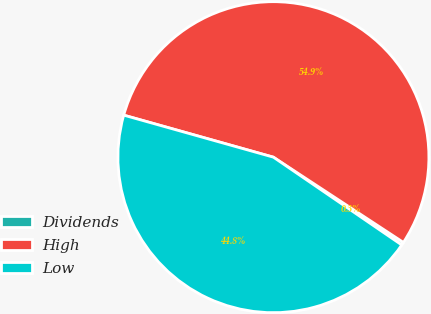<chart> <loc_0><loc_0><loc_500><loc_500><pie_chart><fcel>Dividends<fcel>High<fcel>Low<nl><fcel>0.31%<fcel>54.88%<fcel>44.81%<nl></chart> 